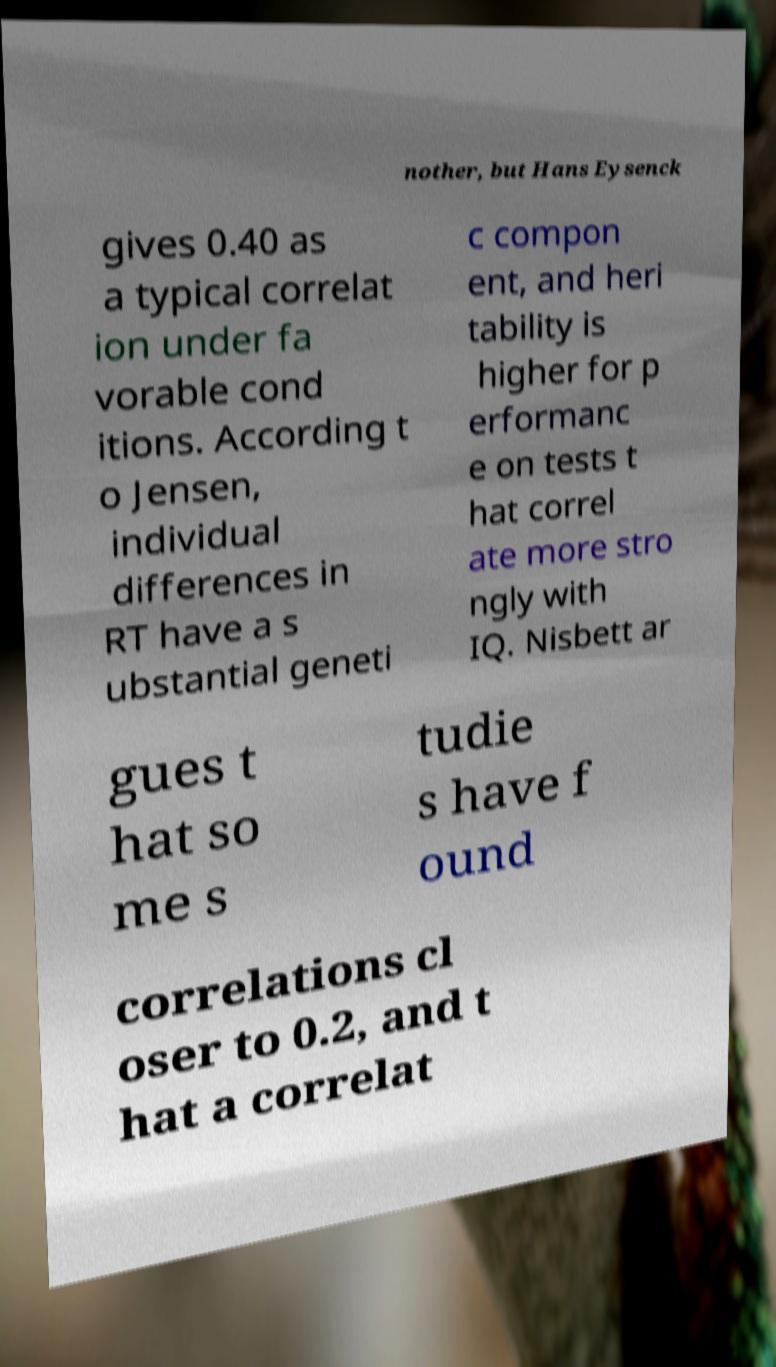Please identify and transcribe the text found in this image. nother, but Hans Eysenck gives 0.40 as a typical correlat ion under fa vorable cond itions. According t o Jensen, individual differences in RT have a s ubstantial geneti c compon ent, and heri tability is higher for p erformanc e on tests t hat correl ate more stro ngly with IQ. Nisbett ar gues t hat so me s tudie s have f ound correlations cl oser to 0.2, and t hat a correlat 